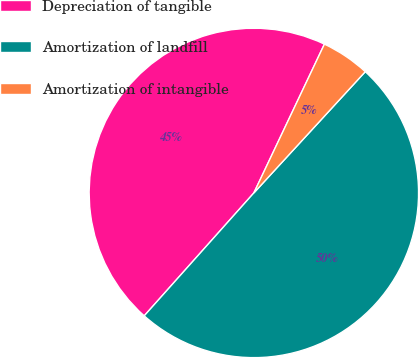<chart> <loc_0><loc_0><loc_500><loc_500><pie_chart><fcel>Depreciation of tangible<fcel>Amortization of landfill<fcel>Amortization of intangible<nl><fcel>45.45%<fcel>49.76%<fcel>4.78%<nl></chart> 